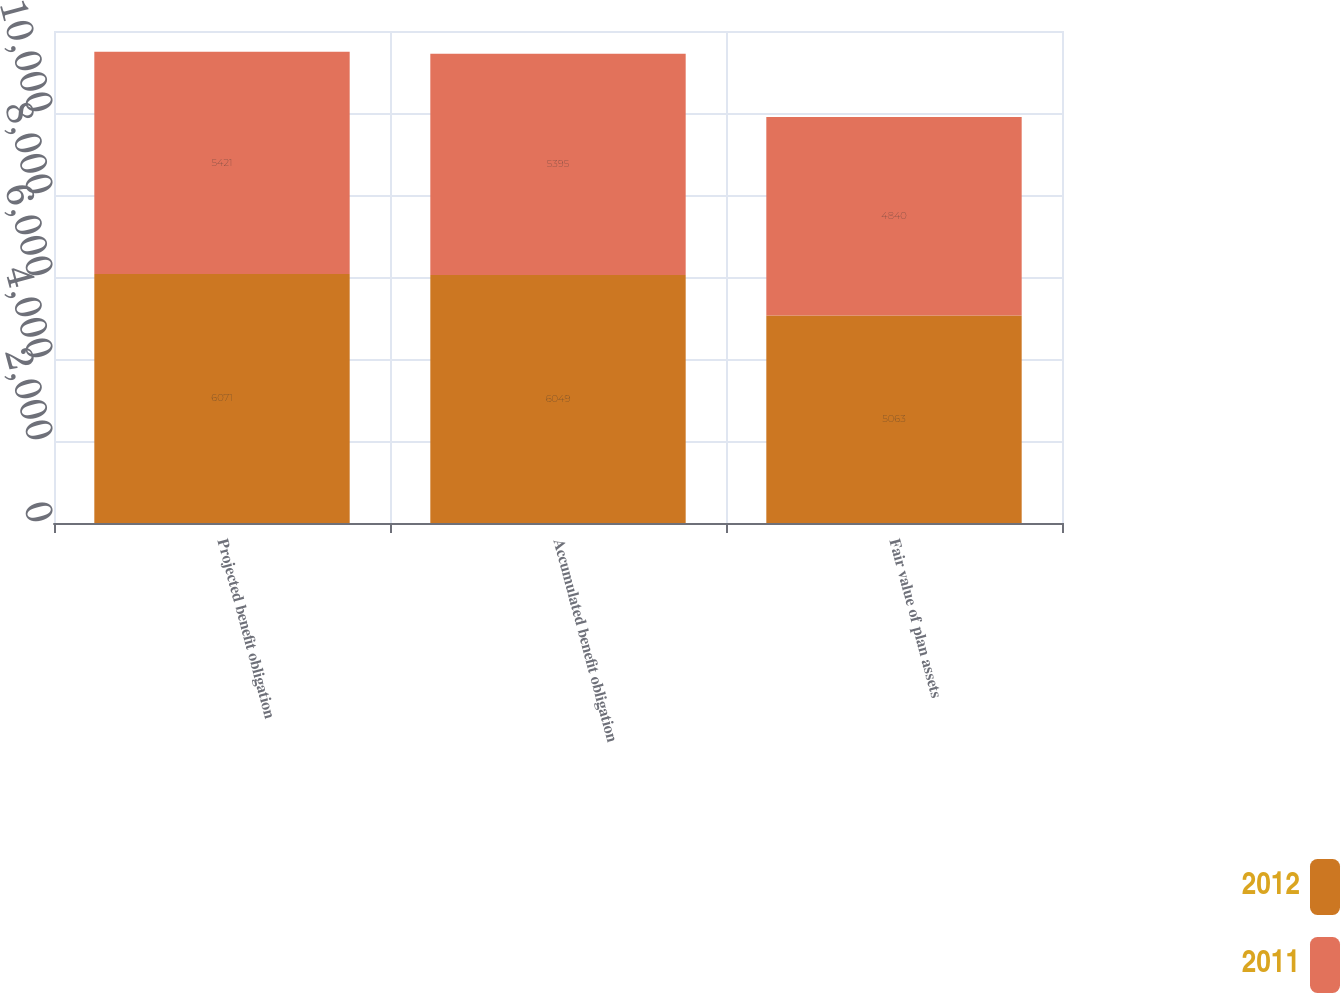<chart> <loc_0><loc_0><loc_500><loc_500><stacked_bar_chart><ecel><fcel>Projected benefit obligation<fcel>Accumulated benefit obligation<fcel>Fair value of plan assets<nl><fcel>2012<fcel>6071<fcel>6049<fcel>5063<nl><fcel>2011<fcel>5421<fcel>5395<fcel>4840<nl></chart> 